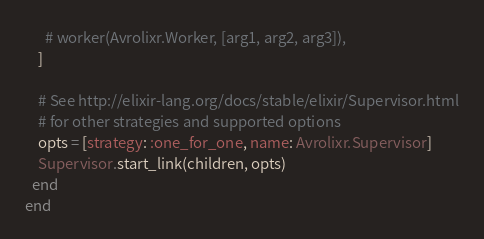<code> <loc_0><loc_0><loc_500><loc_500><_Elixir_>      # worker(Avrolixr.Worker, [arg1, arg2, arg3]),
    ]

    # See http://elixir-lang.org/docs/stable/elixir/Supervisor.html
    # for other strategies and supported options
    opts = [strategy: :one_for_one, name: Avrolixr.Supervisor]
    Supervisor.start_link(children, opts)
  end
end
</code> 